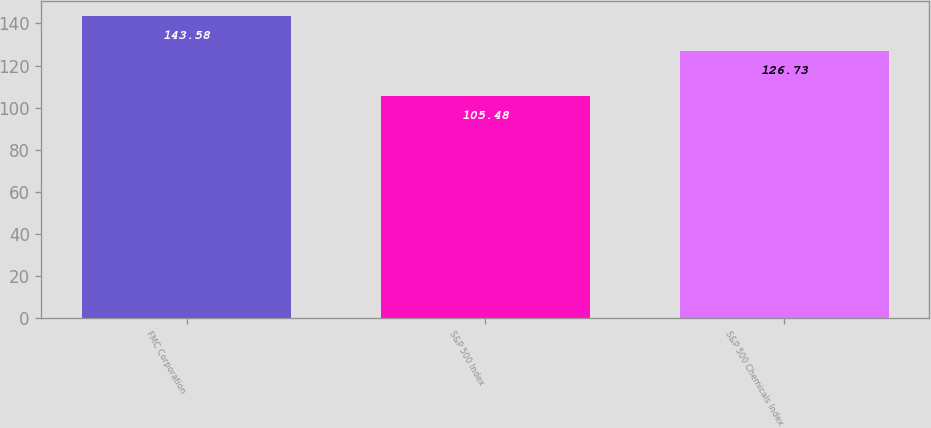Convert chart. <chart><loc_0><loc_0><loc_500><loc_500><bar_chart><fcel>FMC Corporation<fcel>S&P 500 Index<fcel>S&P 500 Chemicals Index<nl><fcel>143.58<fcel>105.48<fcel>126.73<nl></chart> 